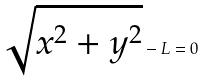Convert formula to latex. <formula><loc_0><loc_0><loc_500><loc_500>\sqrt { x ^ { 2 } + y ^ { 2 } } - L = 0</formula> 